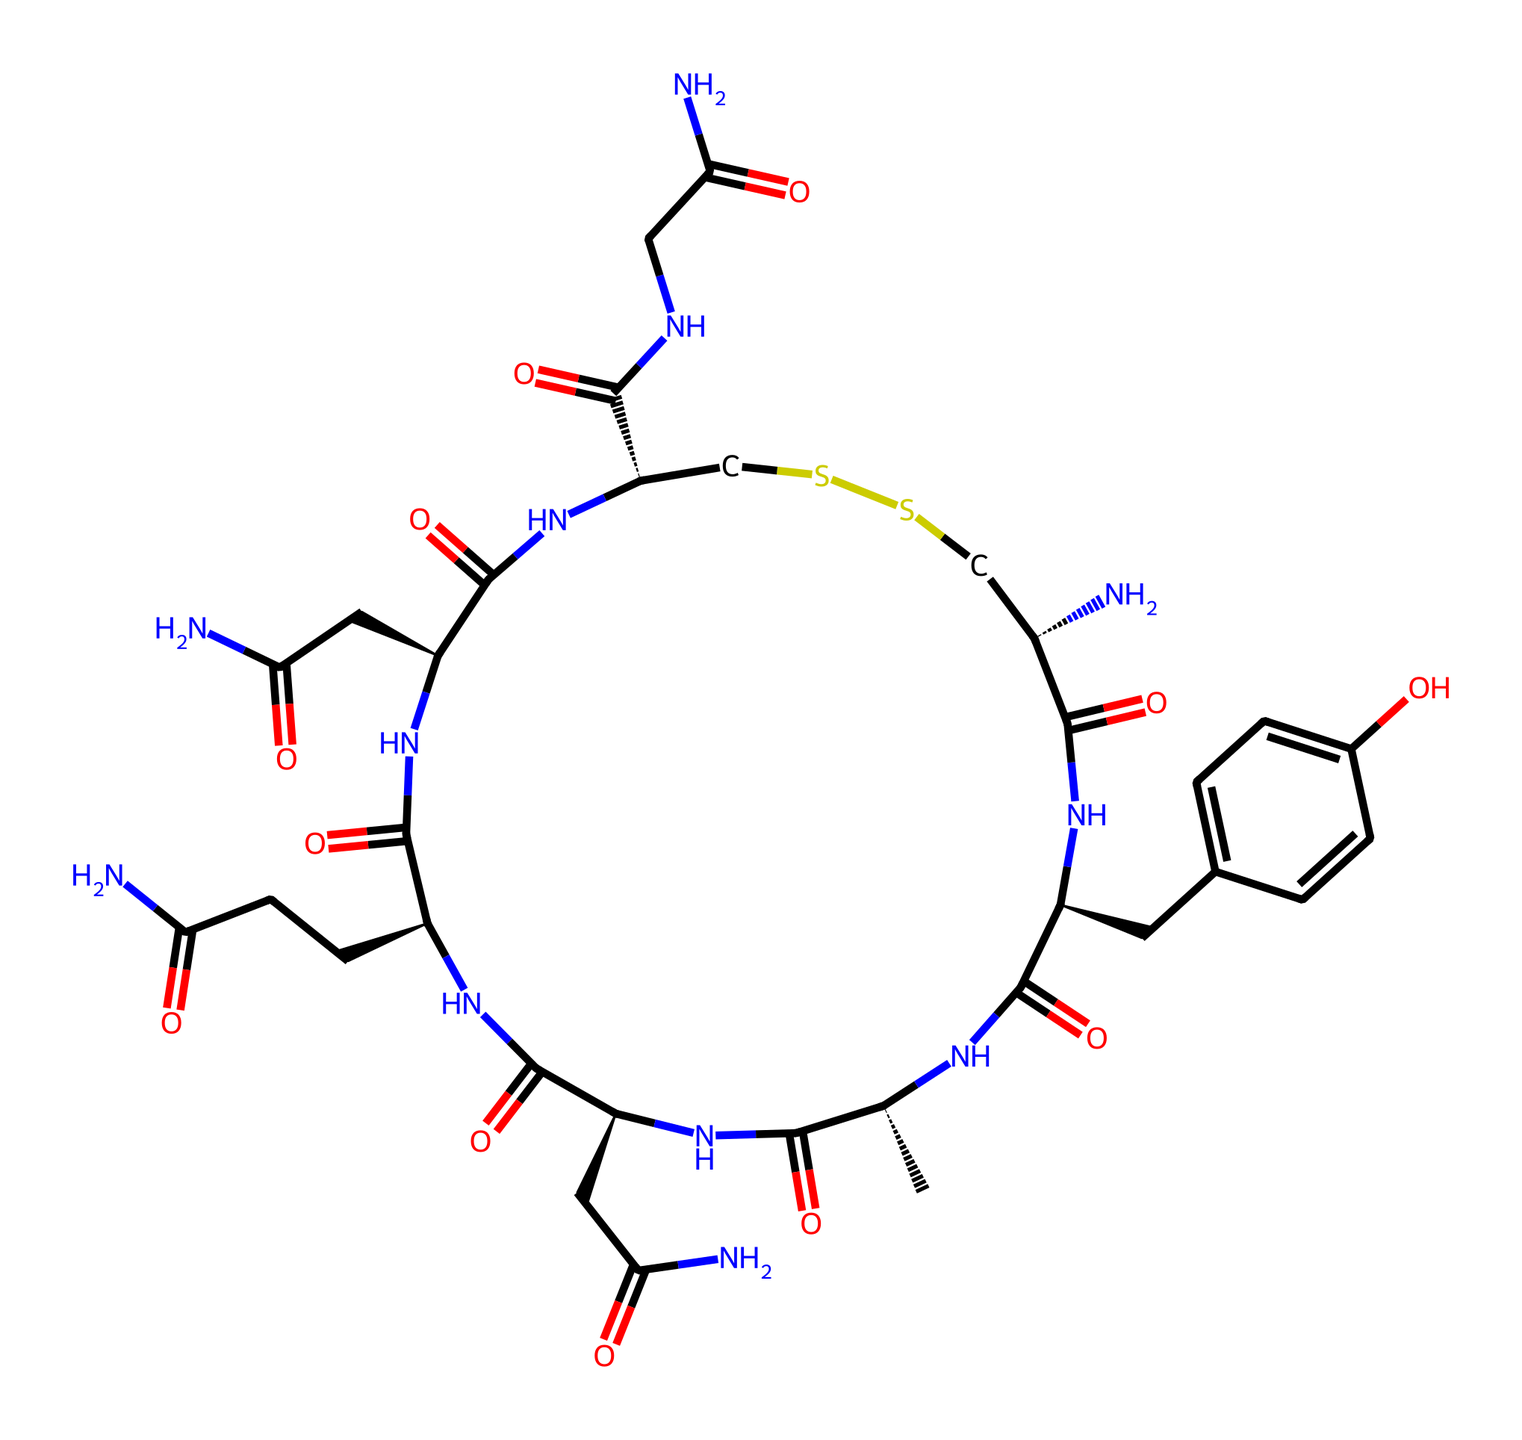How many carbon atoms are in oxytocin? Counting the total number of carbon (C) atoms in the provided SMILES representation reveals 29 carbon atoms. Each carbon contributes to the overall molecular framework of oxytocin.
Answer: 29 What is the main functional group present in oxytocin? The presence of amide groups (as evidenced by the -C(=O)N- linkages in the structure) indicates that the main functional group in oxytocin is amide. This is significant as it relates to the molecule's properties.
Answer: amide How many nitrogen atoms are in oxytocin? By systematically counting the nitrogen (N) atoms in the SMILES representation, we find 6 nitrogen atoms, which contribute to the peptide nature of this hormone.
Answer: 6 What type of bonds are primarily found in oxytocin? The majority of bonds found in oxytocin are peptide (amide) bonds, formed by the connection of amino acids. This is derived from the presence of multiple -C(=O)N- and -C-N- linkages in the structure.
Answer: peptide bonds What type of molecule is oxytocin classified as? Given that oxytocin is a hormone composed of a specific sequence of amino acids, it is classified as a peptide hormone, which characterizes its role in biological signaling.
Answer: peptide hormone What role does the disulfide bond play in oxytocin? The disulfide bond (noted from the -S-S- part of the SMILES) maintains the structural integrity of oxytocin by stabilizing its three-dimensional conformation, essential for its biological function.
Answer: structural stability What effect does oxytocin primarily have in the human body? Oxytocin is primarily known for its role in promoting bonding and trust among individuals, playing a significant part in social behaviors and emotional connections.
Answer: bonding and trust 